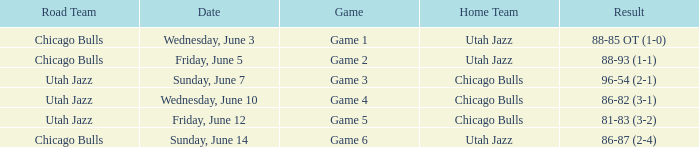Road Team of utah jazz, and a Result of 81-83 (3-2) involved what game? Game 5. Could you help me parse every detail presented in this table? {'header': ['Road Team', 'Date', 'Game', 'Home Team', 'Result'], 'rows': [['Chicago Bulls', 'Wednesday, June 3', 'Game 1', 'Utah Jazz', '88-85 OT (1-0)'], ['Chicago Bulls', 'Friday, June 5', 'Game 2', 'Utah Jazz', '88-93 (1-1)'], ['Utah Jazz', 'Sunday, June 7', 'Game 3', 'Chicago Bulls', '96-54 (2-1)'], ['Utah Jazz', 'Wednesday, June 10', 'Game 4', 'Chicago Bulls', '86-82 (3-1)'], ['Utah Jazz', 'Friday, June 12', 'Game 5', 'Chicago Bulls', '81-83 (3-2)'], ['Chicago Bulls', 'Sunday, June 14', 'Game 6', 'Utah Jazz', '86-87 (2-4)']]} 